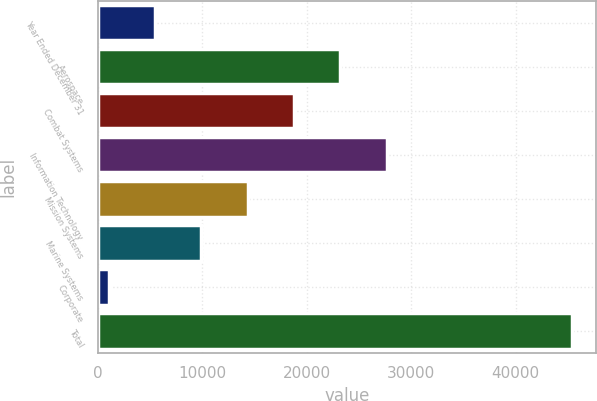<chart> <loc_0><loc_0><loc_500><loc_500><bar_chart><fcel>Year Ended December 31<fcel>Aerospace<fcel>Combat Systems<fcel>Information Technology<fcel>Mission Systems<fcel>Marine Systems<fcel>Corporate<fcel>Total<nl><fcel>5496.6<fcel>23235<fcel>18800.4<fcel>27669.6<fcel>14365.8<fcel>9931.2<fcel>1062<fcel>45408<nl></chart> 